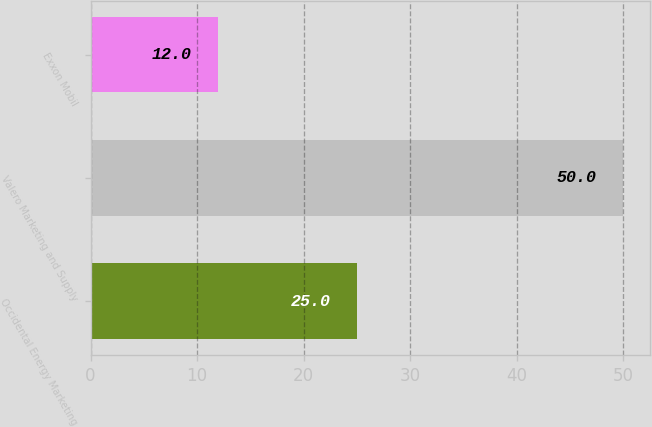Convert chart. <chart><loc_0><loc_0><loc_500><loc_500><bar_chart><fcel>Occidental Energy Marketing<fcel>Valero Marketing and Supply<fcel>Exxon Mobil<nl><fcel>25<fcel>50<fcel>12<nl></chart> 